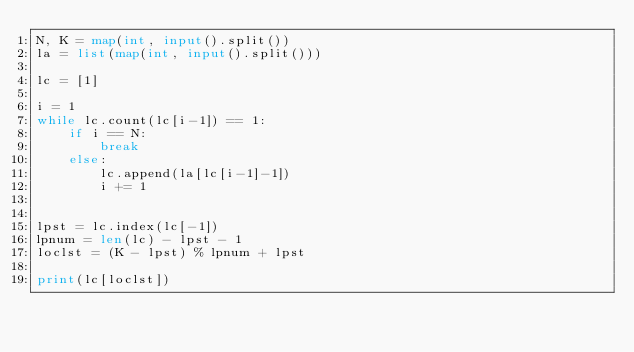Convert code to text. <code><loc_0><loc_0><loc_500><loc_500><_Python_>N, K = map(int, input().split())
la = list(map(int, input().split()))

lc = [1]

i = 1
while lc.count(lc[i-1]) == 1:
    if i == N:
        break
    else:
        lc.append(la[lc[i-1]-1])
        i += 1


lpst = lc.index(lc[-1])
lpnum = len(lc) - lpst - 1
loclst = (K - lpst) % lpnum + lpst

print(lc[loclst])</code> 